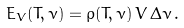<formula> <loc_0><loc_0><loc_500><loc_500>E _ { V } ( T , \nu ) = \rho ( T , \nu ) \, V \, \Delta \nu \, .</formula> 